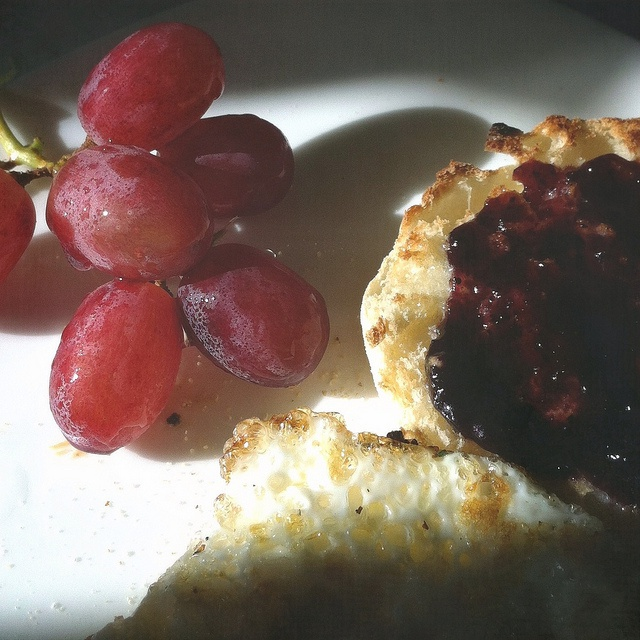Describe the objects in this image and their specific colors. I can see a pizza in black, olive, beige, and khaki tones in this image. 